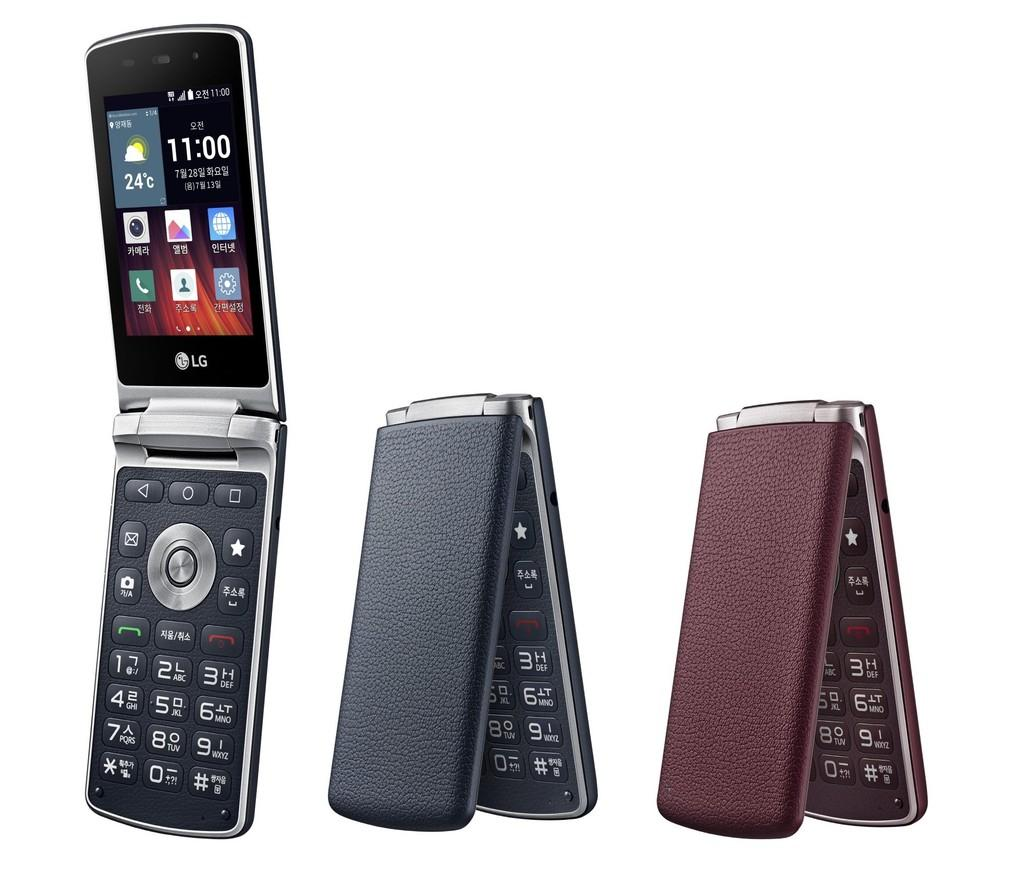<image>
Present a compact description of the photo's key features. Three flip mobile devices are shown which are made by LG. 